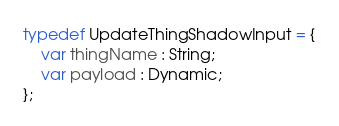<code> <loc_0><loc_0><loc_500><loc_500><_Haxe_>typedef UpdateThingShadowInput = {
    var thingName : String;
    var payload : Dynamic;
};
</code> 